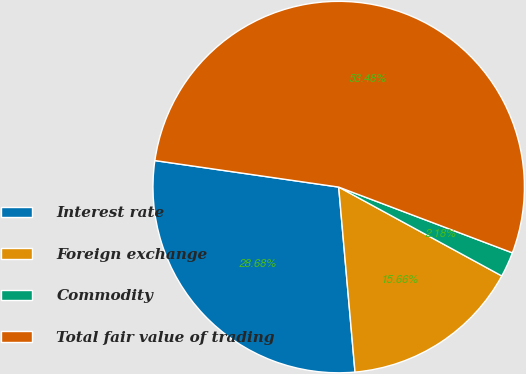Convert chart to OTSL. <chart><loc_0><loc_0><loc_500><loc_500><pie_chart><fcel>Interest rate<fcel>Foreign exchange<fcel>Commodity<fcel>Total fair value of trading<nl><fcel>28.68%<fcel>15.66%<fcel>2.18%<fcel>53.48%<nl></chart> 